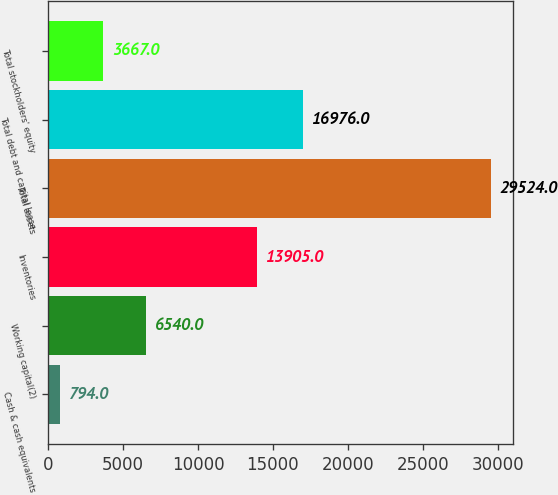<chart> <loc_0><loc_0><loc_500><loc_500><bar_chart><fcel>Cash & cash equivalents<fcel>Working capital(2)<fcel>Inventories<fcel>Total assets<fcel>Total debt and capital lease<fcel>Total stockholders' equity<nl><fcel>794<fcel>6540<fcel>13905<fcel>29524<fcel>16976<fcel>3667<nl></chart> 